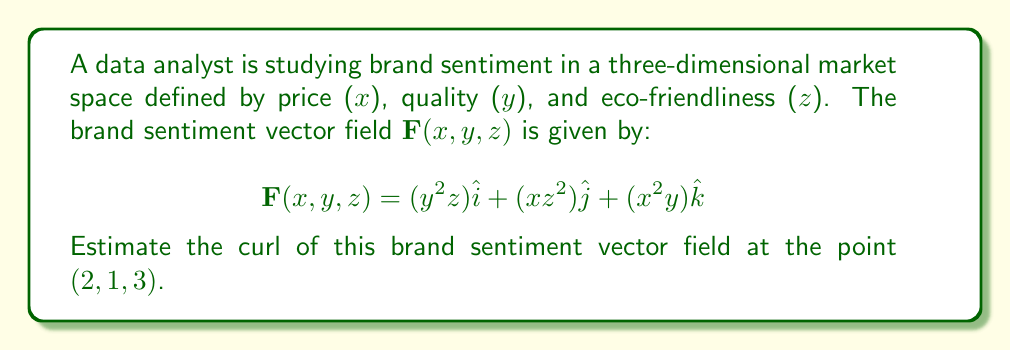Can you solve this math problem? To estimate the curl of the brand sentiment vector field, we need to follow these steps:

1) The curl of a vector field $\mathbf{F}(x,y,z) = P\hat{i} + Q\hat{j} + R\hat{k}$ is defined as:

   $$\text{curl }\mathbf{F} = \nabla \times \mathbf{F} = \left(\frac{\partial R}{\partial y} - \frac{\partial Q}{\partial z}\right)\hat{i} + \left(\frac{\partial P}{\partial z} - \frac{\partial R}{\partial x}\right)\hat{j} + \left(\frac{\partial Q}{\partial x} - \frac{\partial P}{\partial y}\right)\hat{k}$$

2) In our case:
   $P = y^2z$
   $Q = xz^2$
   $R = x^2y$

3) Let's calculate each partial derivative:

   $\frac{\partial R}{\partial y} = x^2$
   $\frac{\partial Q}{\partial z} = 2xz$
   $\frac{\partial P}{\partial z} = y^2$
   $\frac{\partial R}{\partial x} = 2xy$
   $\frac{\partial Q}{\partial x} = z^2$
   $\frac{\partial P}{\partial y} = 2yz$

4) Now we can form the curl:

   $$\text{curl }\mathbf{F} = (x^2 - 2xz)\hat{i} + (y^2 - 2xy)\hat{j} + (z^2 - 2yz)\hat{k}$$

5) To estimate the curl at the point (2, 1, 3), we substitute these values:

   $$\text{curl }\mathbf{F}(2,1,3) = (2^2 - 2(2)(3))\hat{i} + (1^2 - 2(2)(1))\hat{j} + (3^2 - 2(1)(3))\hat{k}$$
   
   $$= (4 - 12)\hat{i} + (1 - 4)\hat{j} + (9 - 6)\hat{k}$$
   
   $$= -8\hat{i} - 3\hat{j} + 3\hat{k}$$

This result represents the curl of the brand sentiment vector field at the given point in the market space.
Answer: $$\text{curl }\mathbf{F}(2,1,3) = -8\hat{i} - 3\hat{j} + 3\hat{k}$$ 